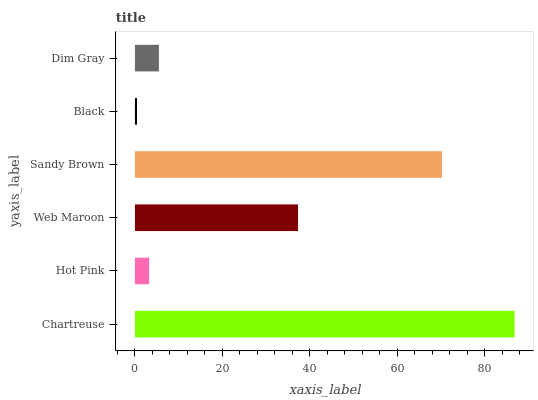Is Black the minimum?
Answer yes or no. Yes. Is Chartreuse the maximum?
Answer yes or no. Yes. Is Hot Pink the minimum?
Answer yes or no. No. Is Hot Pink the maximum?
Answer yes or no. No. Is Chartreuse greater than Hot Pink?
Answer yes or no. Yes. Is Hot Pink less than Chartreuse?
Answer yes or no. Yes. Is Hot Pink greater than Chartreuse?
Answer yes or no. No. Is Chartreuse less than Hot Pink?
Answer yes or no. No. Is Web Maroon the high median?
Answer yes or no. Yes. Is Dim Gray the low median?
Answer yes or no. Yes. Is Hot Pink the high median?
Answer yes or no. No. Is Black the low median?
Answer yes or no. No. 